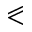Convert formula to latex. <formula><loc_0><loc_0><loc_500><loc_500>\ e q s l a n t l e s s</formula> 